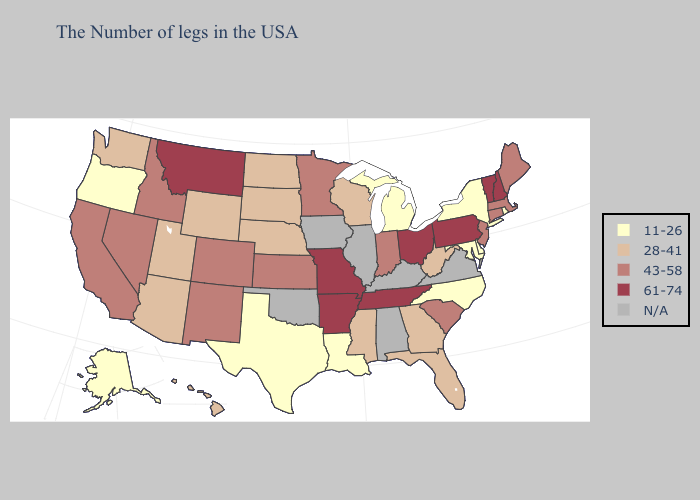Does Wisconsin have the lowest value in the MidWest?
Keep it brief. No. Does Georgia have the lowest value in the South?
Write a very short answer. No. Does the first symbol in the legend represent the smallest category?
Write a very short answer. Yes. Name the states that have a value in the range 43-58?
Be succinct. Maine, Massachusetts, Connecticut, New Jersey, South Carolina, Indiana, Minnesota, Kansas, Colorado, New Mexico, Idaho, Nevada, California. Does Texas have the highest value in the USA?
Short answer required. No. What is the highest value in states that border Ohio?
Short answer required. 61-74. How many symbols are there in the legend?
Write a very short answer. 5. Does Minnesota have the highest value in the USA?
Write a very short answer. No. Name the states that have a value in the range 11-26?
Short answer required. Rhode Island, New York, Delaware, Maryland, North Carolina, Michigan, Louisiana, Texas, Oregon, Alaska. Does Alaska have the lowest value in the West?
Give a very brief answer. Yes. Among the states that border West Virginia , which have the highest value?
Quick response, please. Pennsylvania, Ohio. What is the value of Oklahoma?
Concise answer only. N/A. What is the value of Iowa?
Concise answer only. N/A. 